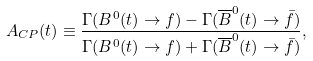<formula> <loc_0><loc_0><loc_500><loc_500>A _ { C P } ( t ) \equiv \frac { \Gamma ( B ^ { 0 } ( t ) \to f ) - \Gamma ( \overline { B } ^ { 0 } ( t ) \to \bar { f } ) } { \Gamma ( B ^ { 0 } ( t ) \to f ) + \Gamma ( \overline { B } ^ { 0 } ( t ) \to \bar { f } ) } ,</formula> 